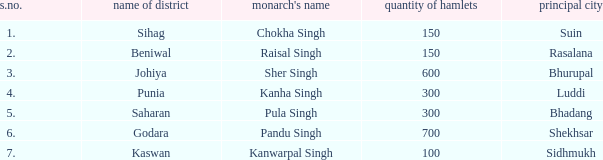Which monarch has an s. number greater than 1 and possesses 600 villages? Sher Singh. 